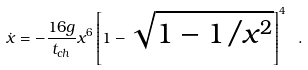<formula> <loc_0><loc_0><loc_500><loc_500>\dot { x } = - \frac { 1 6 g } { t _ { c h } } x ^ { 6 } \left [ 1 - \sqrt { 1 - 1 / x ^ { 2 } } \right ] ^ { 4 } \ .</formula> 